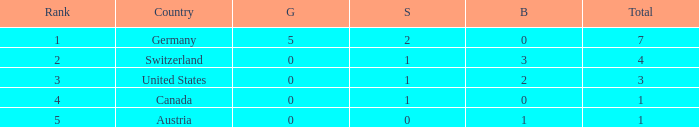What is the full amount of Total for Austria when the number of gold is less than 0? None. 